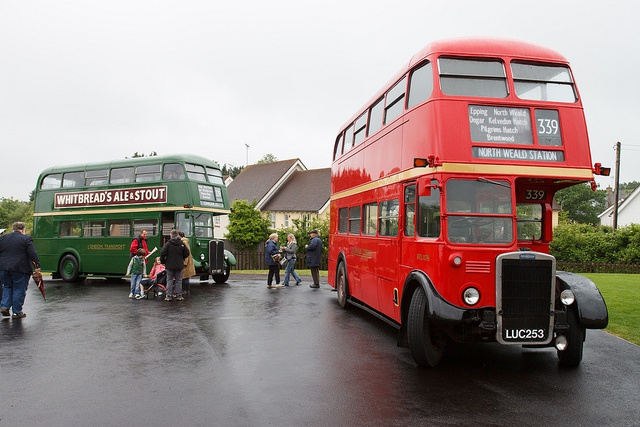Describe the objects in this image and their specific colors. I can see bus in white, black, gray, salmon, and brown tones, bus in white, black, darkgreen, darkgray, and gray tones, people in white, black, navy, darkblue, and gray tones, people in white, black, and gray tones, and people in white, black, gray, and darkgray tones in this image. 